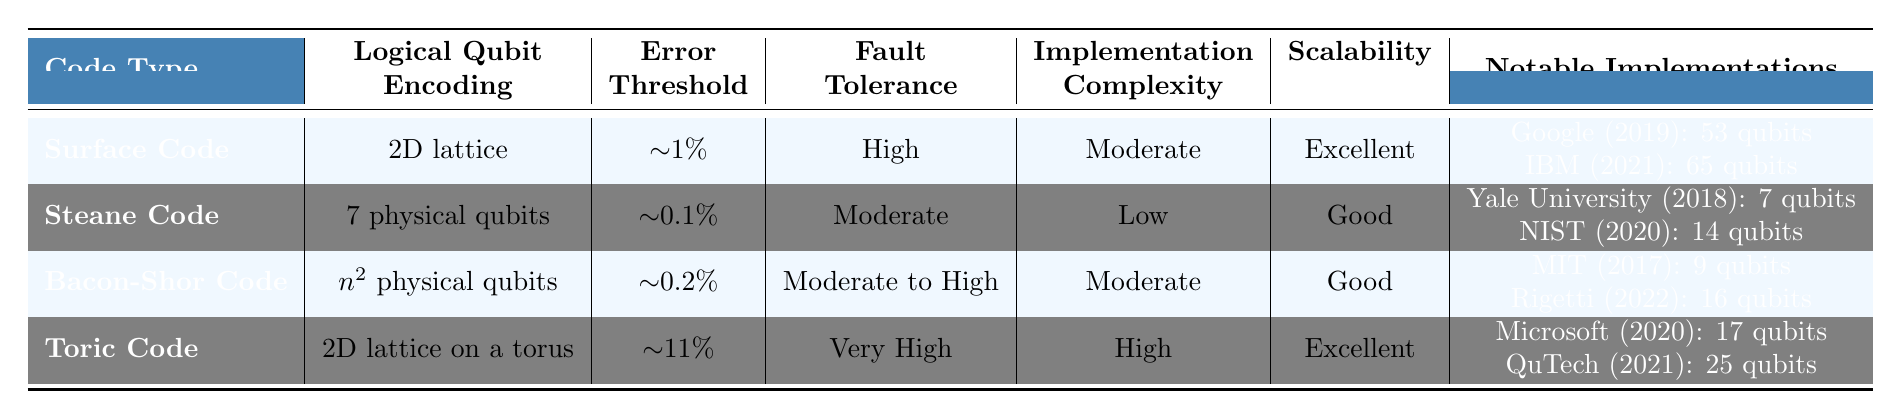What is the error threshold of the Toric Code? The table specifies the error threshold of the Toric Code as approximately 11%.
Answer: ~11% Which error correction code has the highest fault tolerance? According to the table, the Toric Code has the designation of "Very High" for fault tolerance, which is higher than the others listed.
Answer: Toric Code How many qubits did IBM use in their implementation of the Surface Code? The table lists IBM's notable implementation of the Surface Code in 2021, using 65 qubits.
Answer: 65 What is the logical qubit encoding of the Steane Code? The Steane Code is defined in the table as using "7 physical qubits" for logical qubit encoding.
Answer: 7 physical qubits Is the Scalability of the Bacon-Shor Code rated as Excellent? The Scalability of the Bacon-Shor Code is noted as "Good" in the table, which means it is not Excellent.
Answer: No What is the average error threshold of the Surface Code and Bacon-Shor Code? The error thresholds given are ~1% for the Surface Code and ~0.2% for the Bacon-Shor Code. To find the average: (1 + 0.2) / 2 = 0.6%.
Answer: ~0.6% Which code type requires a 2D lattice for logical qubit encoding? The Surface Code and the Toric Code both are noted to require a 2D lattice in their encoding configurations, as shown in the table.
Answer: Surface Code and Toric Code How many notable implementations have been done for the Bacon-Shor Code? The table provides two notable implementations for the Bacon-Shor Code: one by MIT in 2017 and another by Rigetti in 2022.
Answer: 2 Is the implementation complexity of the Toric Code higher than that of the Surface Code? The table lists the implementation complexity of the Toric Code as "High" and that of the Surface Code as "Moderate." Since High is greater than Moderate, the statement is true.
Answer: Yes Which company implemented the Surface Code first and in what year? The first notable implementation of the Surface Code listed is by Google in 2019.
Answer: Google, 2019 